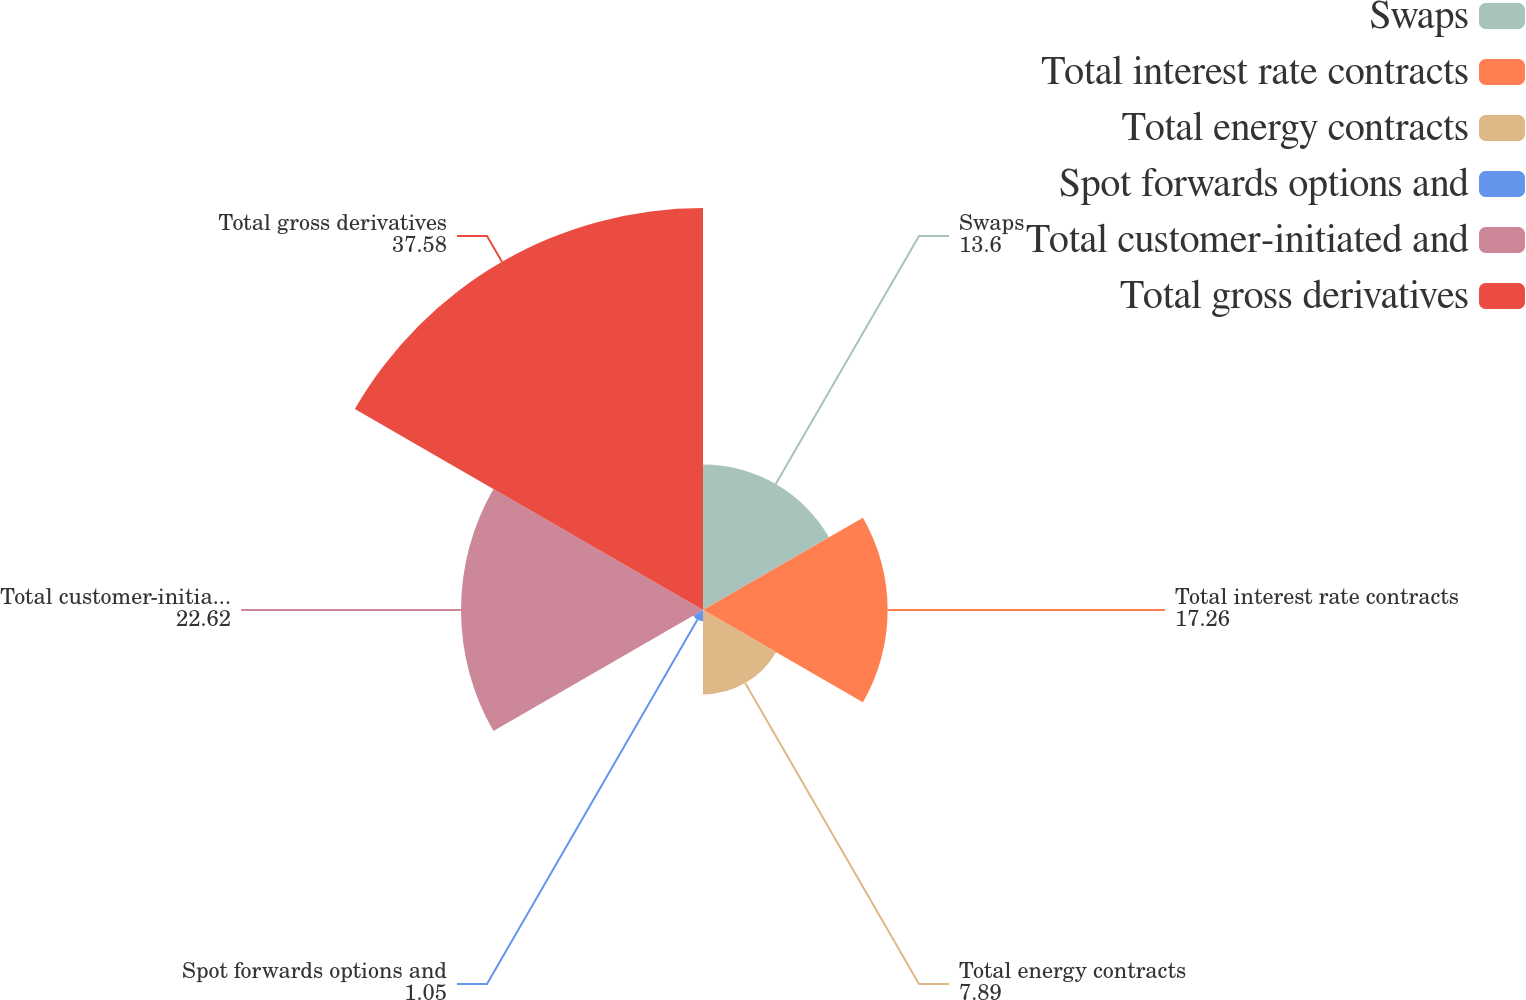<chart> <loc_0><loc_0><loc_500><loc_500><pie_chart><fcel>Swaps<fcel>Total interest rate contracts<fcel>Total energy contracts<fcel>Spot forwards options and<fcel>Total customer-initiated and<fcel>Total gross derivatives<nl><fcel>13.6%<fcel>17.26%<fcel>7.89%<fcel>1.05%<fcel>22.62%<fcel>37.58%<nl></chart> 